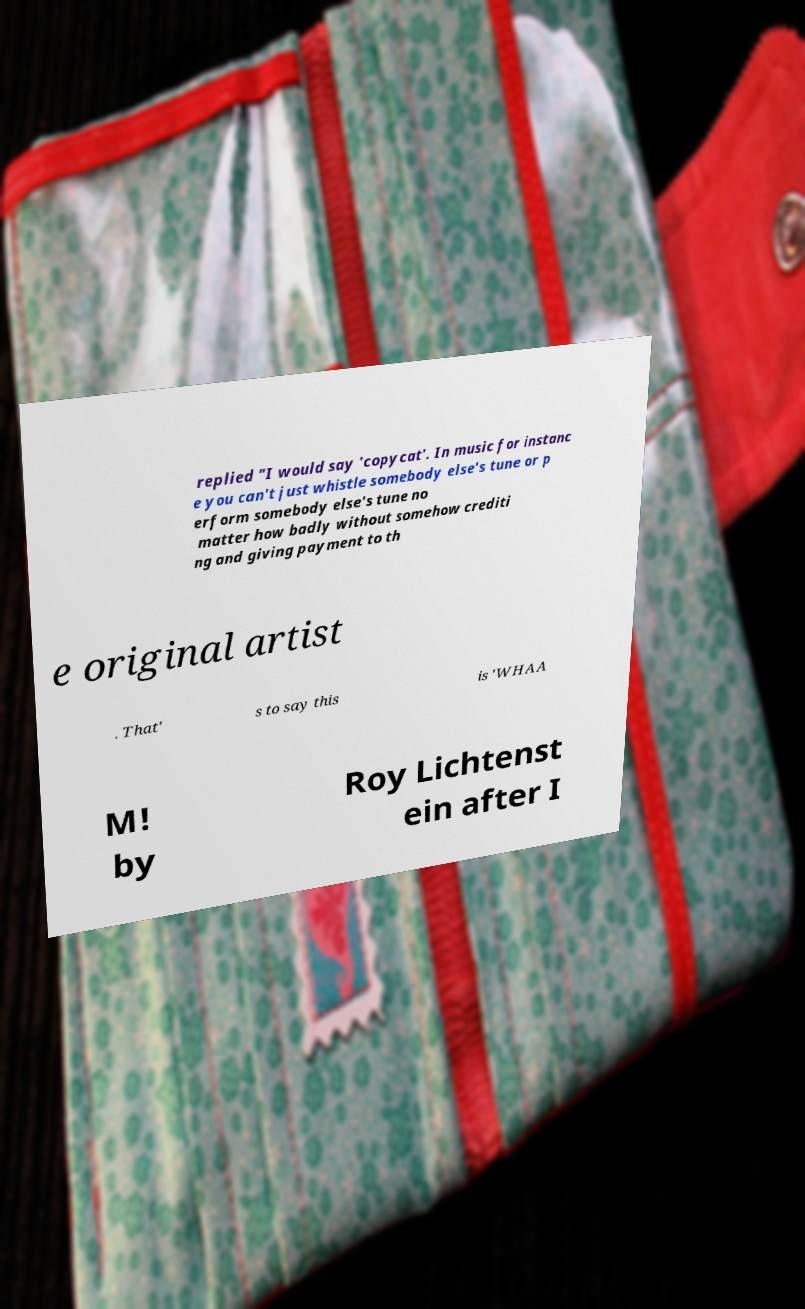For documentation purposes, I need the text within this image transcribed. Could you provide that? replied "I would say 'copycat'. In music for instanc e you can't just whistle somebody else's tune or p erform somebody else's tune no matter how badly without somehow crediti ng and giving payment to th e original artist . That' s to say this is 'WHAA M! by Roy Lichtenst ein after I 